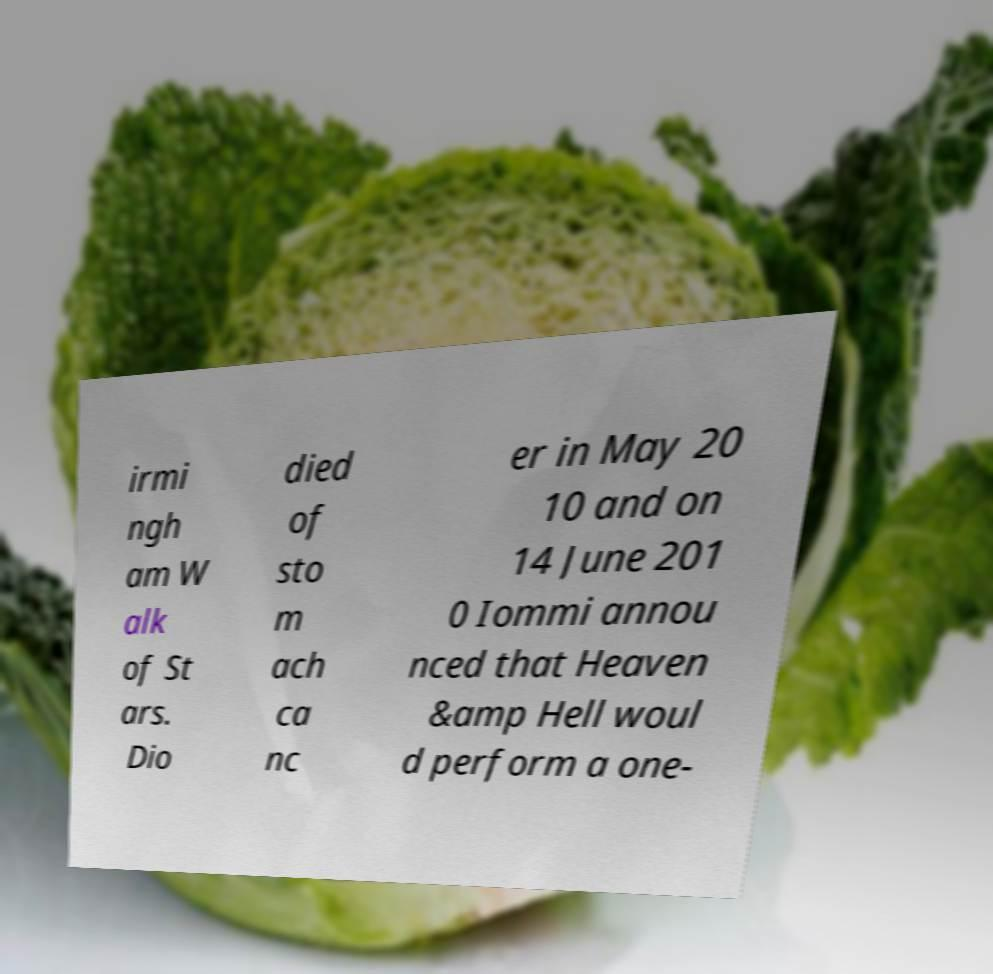Can you read and provide the text displayed in the image?This photo seems to have some interesting text. Can you extract and type it out for me? irmi ngh am W alk of St ars. Dio died of sto m ach ca nc er in May 20 10 and on 14 June 201 0 Iommi annou nced that Heaven &amp Hell woul d perform a one- 